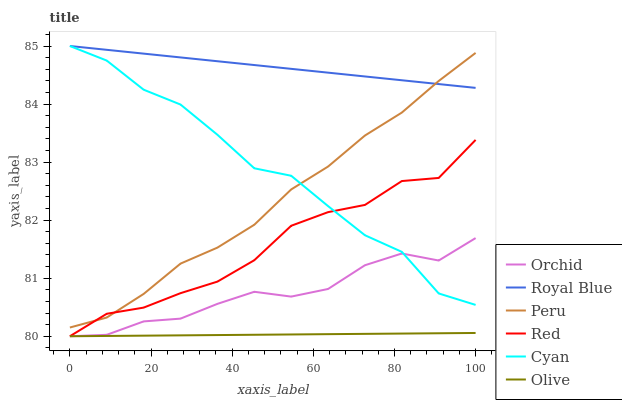Does Olive have the minimum area under the curve?
Answer yes or no. Yes. Does Royal Blue have the maximum area under the curve?
Answer yes or no. Yes. Does Peru have the minimum area under the curve?
Answer yes or no. No. Does Peru have the maximum area under the curve?
Answer yes or no. No. Is Royal Blue the smoothest?
Answer yes or no. Yes. Is Cyan the roughest?
Answer yes or no. Yes. Is Peru the smoothest?
Answer yes or no. No. Is Peru the roughest?
Answer yes or no. No. Does Olive have the lowest value?
Answer yes or no. Yes. Does Peru have the lowest value?
Answer yes or no. No. Does Cyan have the highest value?
Answer yes or no. Yes. Does Peru have the highest value?
Answer yes or no. No. Is Olive less than Royal Blue?
Answer yes or no. Yes. Is Peru greater than Olive?
Answer yes or no. Yes. Does Peru intersect Red?
Answer yes or no. Yes. Is Peru less than Red?
Answer yes or no. No. Is Peru greater than Red?
Answer yes or no. No. Does Olive intersect Royal Blue?
Answer yes or no. No. 